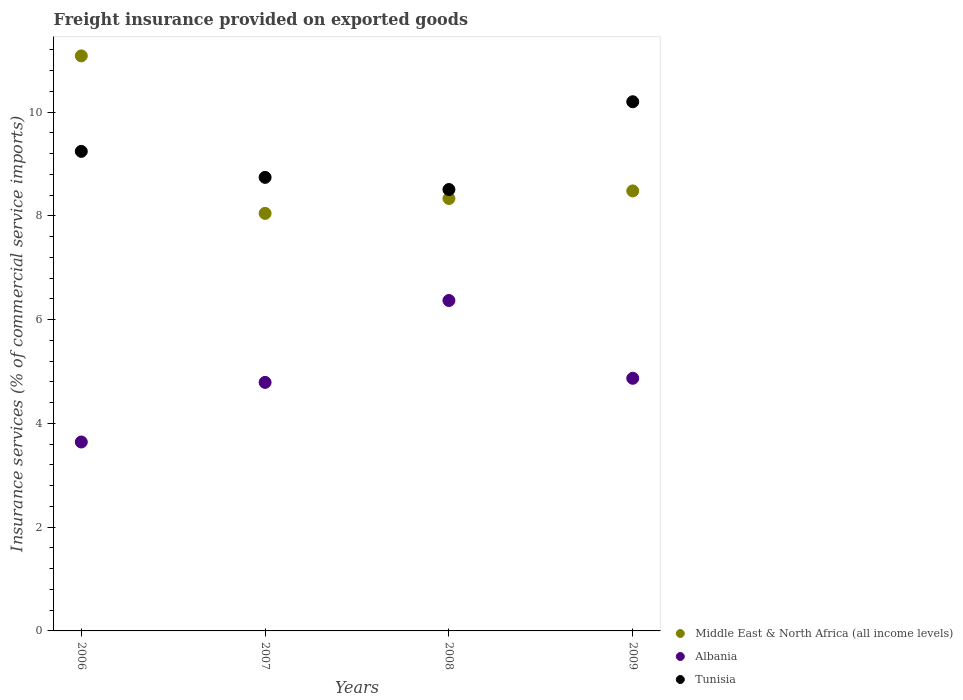How many different coloured dotlines are there?
Offer a very short reply. 3. Is the number of dotlines equal to the number of legend labels?
Give a very brief answer. Yes. What is the freight insurance provided on exported goods in Tunisia in 2006?
Provide a short and direct response. 9.25. Across all years, what is the maximum freight insurance provided on exported goods in Tunisia?
Ensure brevity in your answer.  10.2. Across all years, what is the minimum freight insurance provided on exported goods in Middle East & North Africa (all income levels)?
Give a very brief answer. 8.05. In which year was the freight insurance provided on exported goods in Middle East & North Africa (all income levels) maximum?
Your answer should be compact. 2006. In which year was the freight insurance provided on exported goods in Tunisia minimum?
Your answer should be very brief. 2008. What is the total freight insurance provided on exported goods in Tunisia in the graph?
Keep it short and to the point. 36.7. What is the difference between the freight insurance provided on exported goods in Tunisia in 2007 and that in 2009?
Ensure brevity in your answer.  -1.46. What is the difference between the freight insurance provided on exported goods in Tunisia in 2006 and the freight insurance provided on exported goods in Middle East & North Africa (all income levels) in 2009?
Your answer should be very brief. 0.76. What is the average freight insurance provided on exported goods in Middle East & North Africa (all income levels) per year?
Provide a succinct answer. 8.99. In the year 2009, what is the difference between the freight insurance provided on exported goods in Albania and freight insurance provided on exported goods in Tunisia?
Ensure brevity in your answer.  -5.33. In how many years, is the freight insurance provided on exported goods in Tunisia greater than 10.8 %?
Provide a succinct answer. 0. What is the ratio of the freight insurance provided on exported goods in Middle East & North Africa (all income levels) in 2006 to that in 2008?
Provide a succinct answer. 1.33. Is the freight insurance provided on exported goods in Albania in 2006 less than that in 2008?
Provide a short and direct response. Yes. Is the difference between the freight insurance provided on exported goods in Albania in 2006 and 2009 greater than the difference between the freight insurance provided on exported goods in Tunisia in 2006 and 2009?
Give a very brief answer. No. What is the difference between the highest and the second highest freight insurance provided on exported goods in Tunisia?
Offer a terse response. 0.96. What is the difference between the highest and the lowest freight insurance provided on exported goods in Middle East & North Africa (all income levels)?
Offer a terse response. 3.04. Is the sum of the freight insurance provided on exported goods in Tunisia in 2007 and 2008 greater than the maximum freight insurance provided on exported goods in Albania across all years?
Make the answer very short. Yes. Does the freight insurance provided on exported goods in Tunisia monotonically increase over the years?
Offer a very short reply. No. Where does the legend appear in the graph?
Provide a succinct answer. Bottom right. How are the legend labels stacked?
Give a very brief answer. Vertical. What is the title of the graph?
Your answer should be compact. Freight insurance provided on exported goods. What is the label or title of the X-axis?
Provide a succinct answer. Years. What is the label or title of the Y-axis?
Your answer should be very brief. Insurance services (% of commercial service imports). What is the Insurance services (% of commercial service imports) in Middle East & North Africa (all income levels) in 2006?
Offer a very short reply. 11.09. What is the Insurance services (% of commercial service imports) of Albania in 2006?
Provide a succinct answer. 3.64. What is the Insurance services (% of commercial service imports) of Tunisia in 2006?
Provide a succinct answer. 9.25. What is the Insurance services (% of commercial service imports) in Middle East & North Africa (all income levels) in 2007?
Give a very brief answer. 8.05. What is the Insurance services (% of commercial service imports) of Albania in 2007?
Provide a short and direct response. 4.79. What is the Insurance services (% of commercial service imports) of Tunisia in 2007?
Make the answer very short. 8.74. What is the Insurance services (% of commercial service imports) in Middle East & North Africa (all income levels) in 2008?
Your answer should be very brief. 8.34. What is the Insurance services (% of commercial service imports) in Albania in 2008?
Your response must be concise. 6.37. What is the Insurance services (% of commercial service imports) of Tunisia in 2008?
Provide a succinct answer. 8.51. What is the Insurance services (% of commercial service imports) in Middle East & North Africa (all income levels) in 2009?
Offer a terse response. 8.48. What is the Insurance services (% of commercial service imports) of Albania in 2009?
Provide a short and direct response. 4.87. What is the Insurance services (% of commercial service imports) in Tunisia in 2009?
Your answer should be compact. 10.2. Across all years, what is the maximum Insurance services (% of commercial service imports) in Middle East & North Africa (all income levels)?
Keep it short and to the point. 11.09. Across all years, what is the maximum Insurance services (% of commercial service imports) in Albania?
Ensure brevity in your answer.  6.37. Across all years, what is the maximum Insurance services (% of commercial service imports) of Tunisia?
Offer a very short reply. 10.2. Across all years, what is the minimum Insurance services (% of commercial service imports) of Middle East & North Africa (all income levels)?
Offer a very short reply. 8.05. Across all years, what is the minimum Insurance services (% of commercial service imports) in Albania?
Offer a very short reply. 3.64. Across all years, what is the minimum Insurance services (% of commercial service imports) of Tunisia?
Make the answer very short. 8.51. What is the total Insurance services (% of commercial service imports) in Middle East & North Africa (all income levels) in the graph?
Ensure brevity in your answer.  35.96. What is the total Insurance services (% of commercial service imports) of Albania in the graph?
Your answer should be compact. 19.67. What is the total Insurance services (% of commercial service imports) in Tunisia in the graph?
Offer a terse response. 36.7. What is the difference between the Insurance services (% of commercial service imports) in Middle East & North Africa (all income levels) in 2006 and that in 2007?
Your answer should be very brief. 3.04. What is the difference between the Insurance services (% of commercial service imports) of Albania in 2006 and that in 2007?
Make the answer very short. -1.15. What is the difference between the Insurance services (% of commercial service imports) in Tunisia in 2006 and that in 2007?
Offer a terse response. 0.5. What is the difference between the Insurance services (% of commercial service imports) in Middle East & North Africa (all income levels) in 2006 and that in 2008?
Ensure brevity in your answer.  2.75. What is the difference between the Insurance services (% of commercial service imports) in Albania in 2006 and that in 2008?
Offer a very short reply. -2.73. What is the difference between the Insurance services (% of commercial service imports) in Tunisia in 2006 and that in 2008?
Keep it short and to the point. 0.74. What is the difference between the Insurance services (% of commercial service imports) of Middle East & North Africa (all income levels) in 2006 and that in 2009?
Your answer should be very brief. 2.6. What is the difference between the Insurance services (% of commercial service imports) of Albania in 2006 and that in 2009?
Provide a succinct answer. -1.23. What is the difference between the Insurance services (% of commercial service imports) in Tunisia in 2006 and that in 2009?
Make the answer very short. -0.96. What is the difference between the Insurance services (% of commercial service imports) of Middle East & North Africa (all income levels) in 2007 and that in 2008?
Your answer should be compact. -0.29. What is the difference between the Insurance services (% of commercial service imports) in Albania in 2007 and that in 2008?
Your response must be concise. -1.58. What is the difference between the Insurance services (% of commercial service imports) in Tunisia in 2007 and that in 2008?
Your response must be concise. 0.23. What is the difference between the Insurance services (% of commercial service imports) of Middle East & North Africa (all income levels) in 2007 and that in 2009?
Your answer should be compact. -0.43. What is the difference between the Insurance services (% of commercial service imports) in Albania in 2007 and that in 2009?
Your answer should be very brief. -0.08. What is the difference between the Insurance services (% of commercial service imports) of Tunisia in 2007 and that in 2009?
Provide a short and direct response. -1.46. What is the difference between the Insurance services (% of commercial service imports) in Middle East & North Africa (all income levels) in 2008 and that in 2009?
Your answer should be very brief. -0.15. What is the difference between the Insurance services (% of commercial service imports) in Albania in 2008 and that in 2009?
Give a very brief answer. 1.5. What is the difference between the Insurance services (% of commercial service imports) of Tunisia in 2008 and that in 2009?
Give a very brief answer. -1.69. What is the difference between the Insurance services (% of commercial service imports) of Middle East & North Africa (all income levels) in 2006 and the Insurance services (% of commercial service imports) of Albania in 2007?
Offer a very short reply. 6.3. What is the difference between the Insurance services (% of commercial service imports) of Middle East & North Africa (all income levels) in 2006 and the Insurance services (% of commercial service imports) of Tunisia in 2007?
Make the answer very short. 2.34. What is the difference between the Insurance services (% of commercial service imports) in Albania in 2006 and the Insurance services (% of commercial service imports) in Tunisia in 2007?
Ensure brevity in your answer.  -5.1. What is the difference between the Insurance services (% of commercial service imports) in Middle East & North Africa (all income levels) in 2006 and the Insurance services (% of commercial service imports) in Albania in 2008?
Offer a terse response. 4.72. What is the difference between the Insurance services (% of commercial service imports) of Middle East & North Africa (all income levels) in 2006 and the Insurance services (% of commercial service imports) of Tunisia in 2008?
Offer a very short reply. 2.58. What is the difference between the Insurance services (% of commercial service imports) of Albania in 2006 and the Insurance services (% of commercial service imports) of Tunisia in 2008?
Your response must be concise. -4.87. What is the difference between the Insurance services (% of commercial service imports) in Middle East & North Africa (all income levels) in 2006 and the Insurance services (% of commercial service imports) in Albania in 2009?
Your answer should be compact. 6.22. What is the difference between the Insurance services (% of commercial service imports) of Middle East & North Africa (all income levels) in 2006 and the Insurance services (% of commercial service imports) of Tunisia in 2009?
Your answer should be very brief. 0.88. What is the difference between the Insurance services (% of commercial service imports) in Albania in 2006 and the Insurance services (% of commercial service imports) in Tunisia in 2009?
Make the answer very short. -6.56. What is the difference between the Insurance services (% of commercial service imports) in Middle East & North Africa (all income levels) in 2007 and the Insurance services (% of commercial service imports) in Albania in 2008?
Your answer should be compact. 1.68. What is the difference between the Insurance services (% of commercial service imports) in Middle East & North Africa (all income levels) in 2007 and the Insurance services (% of commercial service imports) in Tunisia in 2008?
Give a very brief answer. -0.46. What is the difference between the Insurance services (% of commercial service imports) in Albania in 2007 and the Insurance services (% of commercial service imports) in Tunisia in 2008?
Your answer should be very brief. -3.72. What is the difference between the Insurance services (% of commercial service imports) in Middle East & North Africa (all income levels) in 2007 and the Insurance services (% of commercial service imports) in Albania in 2009?
Ensure brevity in your answer.  3.18. What is the difference between the Insurance services (% of commercial service imports) in Middle East & North Africa (all income levels) in 2007 and the Insurance services (% of commercial service imports) in Tunisia in 2009?
Your answer should be very brief. -2.15. What is the difference between the Insurance services (% of commercial service imports) of Albania in 2007 and the Insurance services (% of commercial service imports) of Tunisia in 2009?
Offer a terse response. -5.41. What is the difference between the Insurance services (% of commercial service imports) in Middle East & North Africa (all income levels) in 2008 and the Insurance services (% of commercial service imports) in Albania in 2009?
Your answer should be very brief. 3.47. What is the difference between the Insurance services (% of commercial service imports) of Middle East & North Africa (all income levels) in 2008 and the Insurance services (% of commercial service imports) of Tunisia in 2009?
Make the answer very short. -1.87. What is the difference between the Insurance services (% of commercial service imports) of Albania in 2008 and the Insurance services (% of commercial service imports) of Tunisia in 2009?
Offer a terse response. -3.83. What is the average Insurance services (% of commercial service imports) in Middle East & North Africa (all income levels) per year?
Provide a short and direct response. 8.99. What is the average Insurance services (% of commercial service imports) in Albania per year?
Offer a very short reply. 4.92. What is the average Insurance services (% of commercial service imports) of Tunisia per year?
Offer a terse response. 9.18. In the year 2006, what is the difference between the Insurance services (% of commercial service imports) of Middle East & North Africa (all income levels) and Insurance services (% of commercial service imports) of Albania?
Your answer should be very brief. 7.44. In the year 2006, what is the difference between the Insurance services (% of commercial service imports) in Middle East & North Africa (all income levels) and Insurance services (% of commercial service imports) in Tunisia?
Make the answer very short. 1.84. In the year 2006, what is the difference between the Insurance services (% of commercial service imports) of Albania and Insurance services (% of commercial service imports) of Tunisia?
Your answer should be very brief. -5.6. In the year 2007, what is the difference between the Insurance services (% of commercial service imports) in Middle East & North Africa (all income levels) and Insurance services (% of commercial service imports) in Albania?
Make the answer very short. 3.26. In the year 2007, what is the difference between the Insurance services (% of commercial service imports) in Middle East & North Africa (all income levels) and Insurance services (% of commercial service imports) in Tunisia?
Provide a succinct answer. -0.69. In the year 2007, what is the difference between the Insurance services (% of commercial service imports) of Albania and Insurance services (% of commercial service imports) of Tunisia?
Keep it short and to the point. -3.95. In the year 2008, what is the difference between the Insurance services (% of commercial service imports) of Middle East & North Africa (all income levels) and Insurance services (% of commercial service imports) of Albania?
Ensure brevity in your answer.  1.97. In the year 2008, what is the difference between the Insurance services (% of commercial service imports) in Middle East & North Africa (all income levels) and Insurance services (% of commercial service imports) in Tunisia?
Provide a succinct answer. -0.17. In the year 2008, what is the difference between the Insurance services (% of commercial service imports) of Albania and Insurance services (% of commercial service imports) of Tunisia?
Your answer should be compact. -2.14. In the year 2009, what is the difference between the Insurance services (% of commercial service imports) in Middle East & North Africa (all income levels) and Insurance services (% of commercial service imports) in Albania?
Your answer should be very brief. 3.61. In the year 2009, what is the difference between the Insurance services (% of commercial service imports) of Middle East & North Africa (all income levels) and Insurance services (% of commercial service imports) of Tunisia?
Make the answer very short. -1.72. In the year 2009, what is the difference between the Insurance services (% of commercial service imports) of Albania and Insurance services (% of commercial service imports) of Tunisia?
Offer a very short reply. -5.33. What is the ratio of the Insurance services (% of commercial service imports) in Middle East & North Africa (all income levels) in 2006 to that in 2007?
Offer a terse response. 1.38. What is the ratio of the Insurance services (% of commercial service imports) in Albania in 2006 to that in 2007?
Your answer should be compact. 0.76. What is the ratio of the Insurance services (% of commercial service imports) in Tunisia in 2006 to that in 2007?
Make the answer very short. 1.06. What is the ratio of the Insurance services (% of commercial service imports) in Middle East & North Africa (all income levels) in 2006 to that in 2008?
Ensure brevity in your answer.  1.33. What is the ratio of the Insurance services (% of commercial service imports) of Albania in 2006 to that in 2008?
Your answer should be compact. 0.57. What is the ratio of the Insurance services (% of commercial service imports) in Tunisia in 2006 to that in 2008?
Give a very brief answer. 1.09. What is the ratio of the Insurance services (% of commercial service imports) in Middle East & North Africa (all income levels) in 2006 to that in 2009?
Provide a succinct answer. 1.31. What is the ratio of the Insurance services (% of commercial service imports) in Albania in 2006 to that in 2009?
Ensure brevity in your answer.  0.75. What is the ratio of the Insurance services (% of commercial service imports) in Tunisia in 2006 to that in 2009?
Make the answer very short. 0.91. What is the ratio of the Insurance services (% of commercial service imports) of Middle East & North Africa (all income levels) in 2007 to that in 2008?
Keep it short and to the point. 0.97. What is the ratio of the Insurance services (% of commercial service imports) of Albania in 2007 to that in 2008?
Offer a very short reply. 0.75. What is the ratio of the Insurance services (% of commercial service imports) in Tunisia in 2007 to that in 2008?
Make the answer very short. 1.03. What is the ratio of the Insurance services (% of commercial service imports) in Middle East & North Africa (all income levels) in 2007 to that in 2009?
Your answer should be very brief. 0.95. What is the ratio of the Insurance services (% of commercial service imports) of Albania in 2007 to that in 2009?
Your answer should be compact. 0.98. What is the ratio of the Insurance services (% of commercial service imports) in Tunisia in 2007 to that in 2009?
Keep it short and to the point. 0.86. What is the ratio of the Insurance services (% of commercial service imports) of Middle East & North Africa (all income levels) in 2008 to that in 2009?
Offer a very short reply. 0.98. What is the ratio of the Insurance services (% of commercial service imports) of Albania in 2008 to that in 2009?
Ensure brevity in your answer.  1.31. What is the ratio of the Insurance services (% of commercial service imports) of Tunisia in 2008 to that in 2009?
Offer a very short reply. 0.83. What is the difference between the highest and the second highest Insurance services (% of commercial service imports) of Middle East & North Africa (all income levels)?
Keep it short and to the point. 2.6. What is the difference between the highest and the second highest Insurance services (% of commercial service imports) of Albania?
Your response must be concise. 1.5. What is the difference between the highest and the second highest Insurance services (% of commercial service imports) of Tunisia?
Provide a succinct answer. 0.96. What is the difference between the highest and the lowest Insurance services (% of commercial service imports) of Middle East & North Africa (all income levels)?
Your answer should be very brief. 3.04. What is the difference between the highest and the lowest Insurance services (% of commercial service imports) in Albania?
Your answer should be very brief. 2.73. What is the difference between the highest and the lowest Insurance services (% of commercial service imports) in Tunisia?
Offer a very short reply. 1.69. 